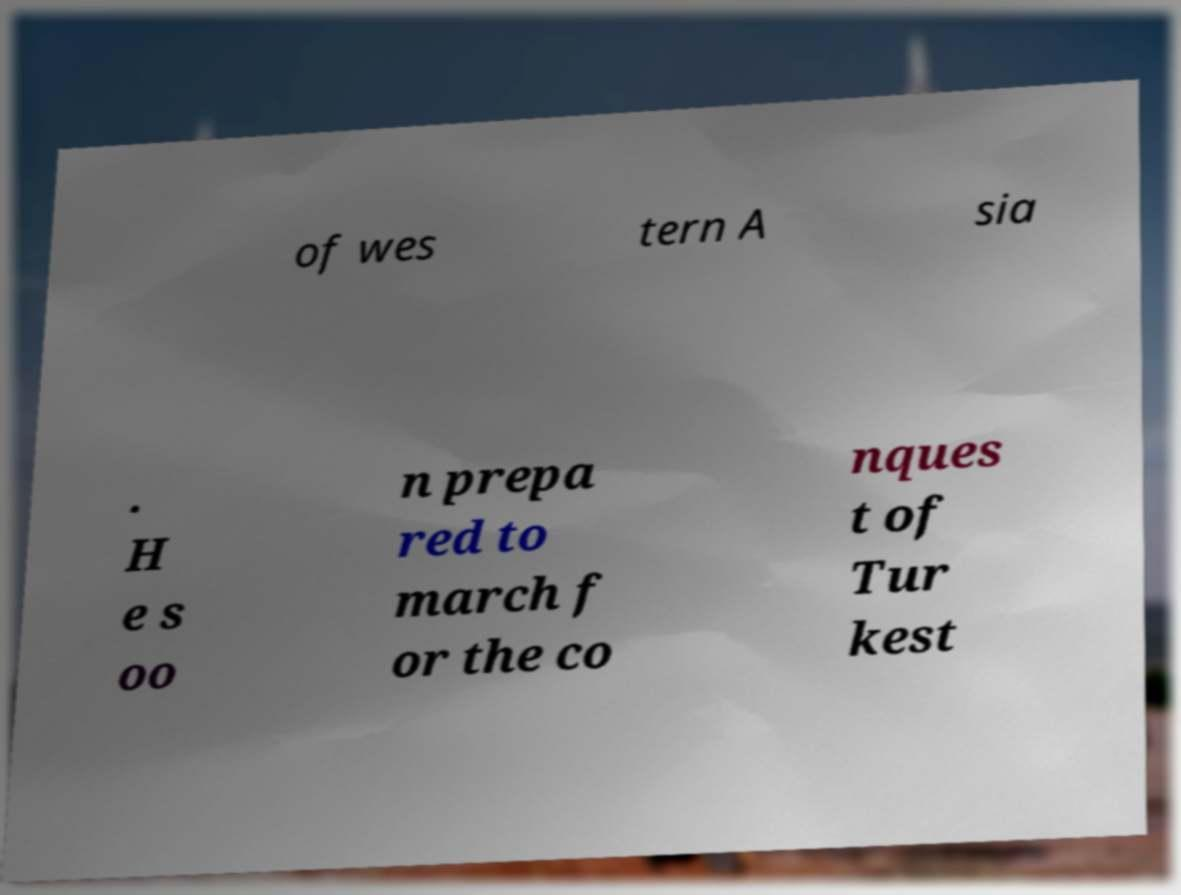There's text embedded in this image that I need extracted. Can you transcribe it verbatim? of wes tern A sia . H e s oo n prepa red to march f or the co nques t of Tur kest 